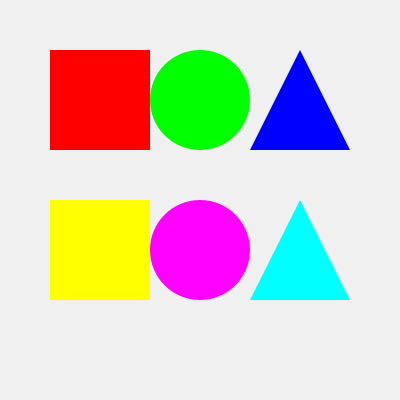Identify which shape and color combination represents the traditional pattern from the Andean region of South America: To identify the traditional pattern from the Andean region of South America, we need to consider the following steps:

1. Analyze the shapes and colors presented in the image:
   - Red square
   - Green circle
   - Blue triangle
   - Yellow square
   - Pink circle
   - Cyan triangle

2. Recall the characteristics of Andean patterns:
   - Geometric shapes are common in Andean designs
   - Bright, contrasting colors are typically used
   - Triangles and diamonds are particularly significant in Andean symbolism

3. Consider the cultural significance:
   - Triangles often represent mountains in Andean culture
   - The color blue is associated with the sky and water in many Andean traditions

4. Match the characteristics with the options:
   - The blue triangle aligns most closely with Andean design principles

5. Eliminate other options:
   - Squares and circles are less characteristic of traditional Andean patterns
   - The other color combinations don't as strongly represent Andean symbolism

Therefore, the blue triangle is the most likely representation of a traditional pattern from the Andean region of South America.
Answer: Blue triangle 